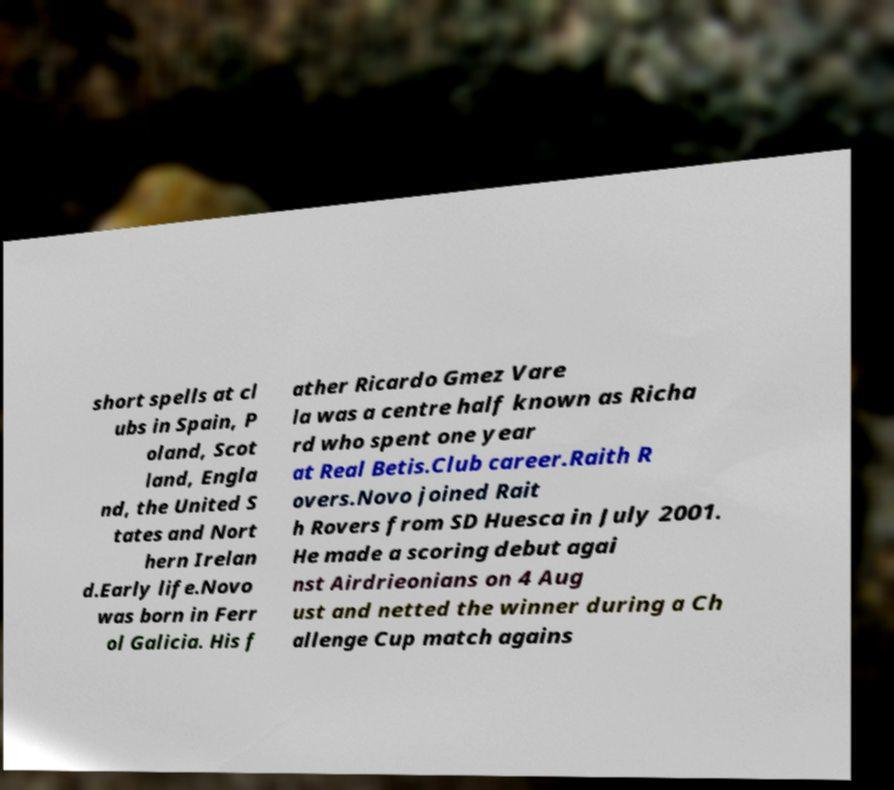I need the written content from this picture converted into text. Can you do that? short spells at cl ubs in Spain, P oland, Scot land, Engla nd, the United S tates and Nort hern Irelan d.Early life.Novo was born in Ferr ol Galicia. His f ather Ricardo Gmez Vare la was a centre half known as Richa rd who spent one year at Real Betis.Club career.Raith R overs.Novo joined Rait h Rovers from SD Huesca in July 2001. He made a scoring debut agai nst Airdrieonians on 4 Aug ust and netted the winner during a Ch allenge Cup match agains 